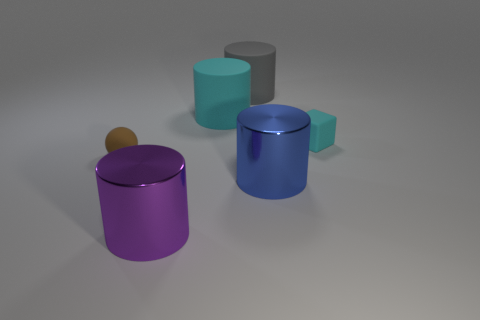Is the blue shiny object the same shape as the purple thing?
Make the answer very short. Yes. What is the shape of the large matte object that is the same color as the tiny matte cube?
Provide a short and direct response. Cylinder. There is a cyan cube that is the same material as the sphere; what is its size?
Keep it short and to the point. Small. Is there a large cylinder of the same color as the rubber block?
Your answer should be very brief. Yes. The matte cylinder that is the same color as the tiny block is what size?
Your answer should be compact. Large. There is a blue cylinder; are there any big cylinders behind it?
Provide a succinct answer. Yes. There is a tiny cyan thing; what shape is it?
Offer a terse response. Cube. There is a gray rubber thing to the left of the tiny object to the right of the metal object that is behind the purple metallic object; what shape is it?
Provide a succinct answer. Cylinder. What number of other objects are the same shape as the blue metal object?
Keep it short and to the point. 3. What is the gray object left of the tiny matte object that is behind the small brown ball made of?
Offer a very short reply. Rubber. 